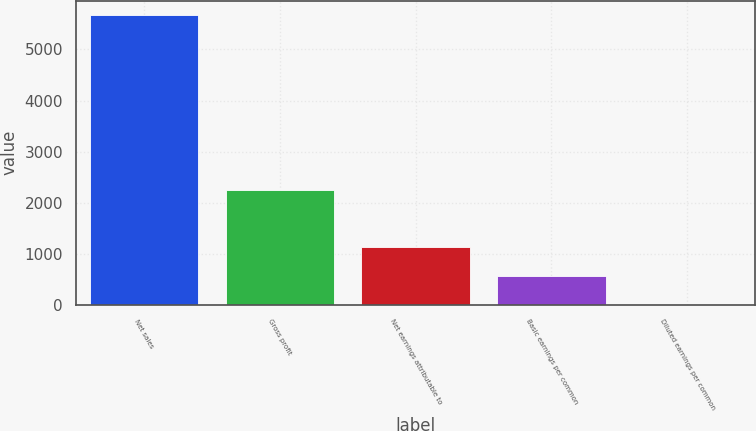Convert chart. <chart><loc_0><loc_0><loc_500><loc_500><bar_chart><fcel>Net sales<fcel>Gross profit<fcel>Net earnings attributable to<fcel>Basic earnings per common<fcel>Diluted earnings per common<nl><fcel>5671.4<fcel>2249.7<fcel>1139.07<fcel>572.53<fcel>5.99<nl></chart> 